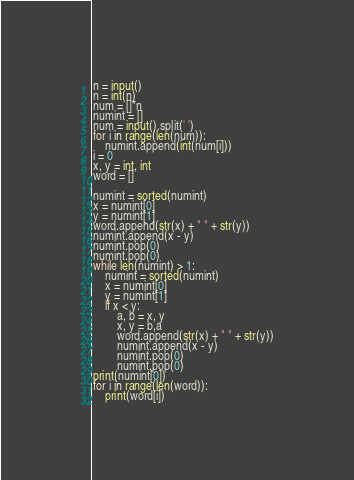<code> <loc_0><loc_0><loc_500><loc_500><_Python_>n = input()
n = int(n)
num = []*n
numint = []
num = input().split(' ')
for i in range(len(num)):
    numint.append(int(num[i]))
i = 0
x, y = int, int
word = []

numint = sorted(numint)
x = numint[0]
y = numint[1]
word.append(str(x) + " " + str(y))
numint.append(x - y)
numint.pop(0)
numint.pop(0)
while len(numint) > 1:
    numint = sorted(numint)
    x = numint[0]
    y = numint[1]
    if x < y:
        a, b = x, y
        x, y = b,a
        word.append(str(x) + " " + str(y))
        numint.append(x - y)
        numint.pop(0)
        numint.pop(0)
print(numint[0])
for i in range(len(word)):
    print(word[i])</code> 